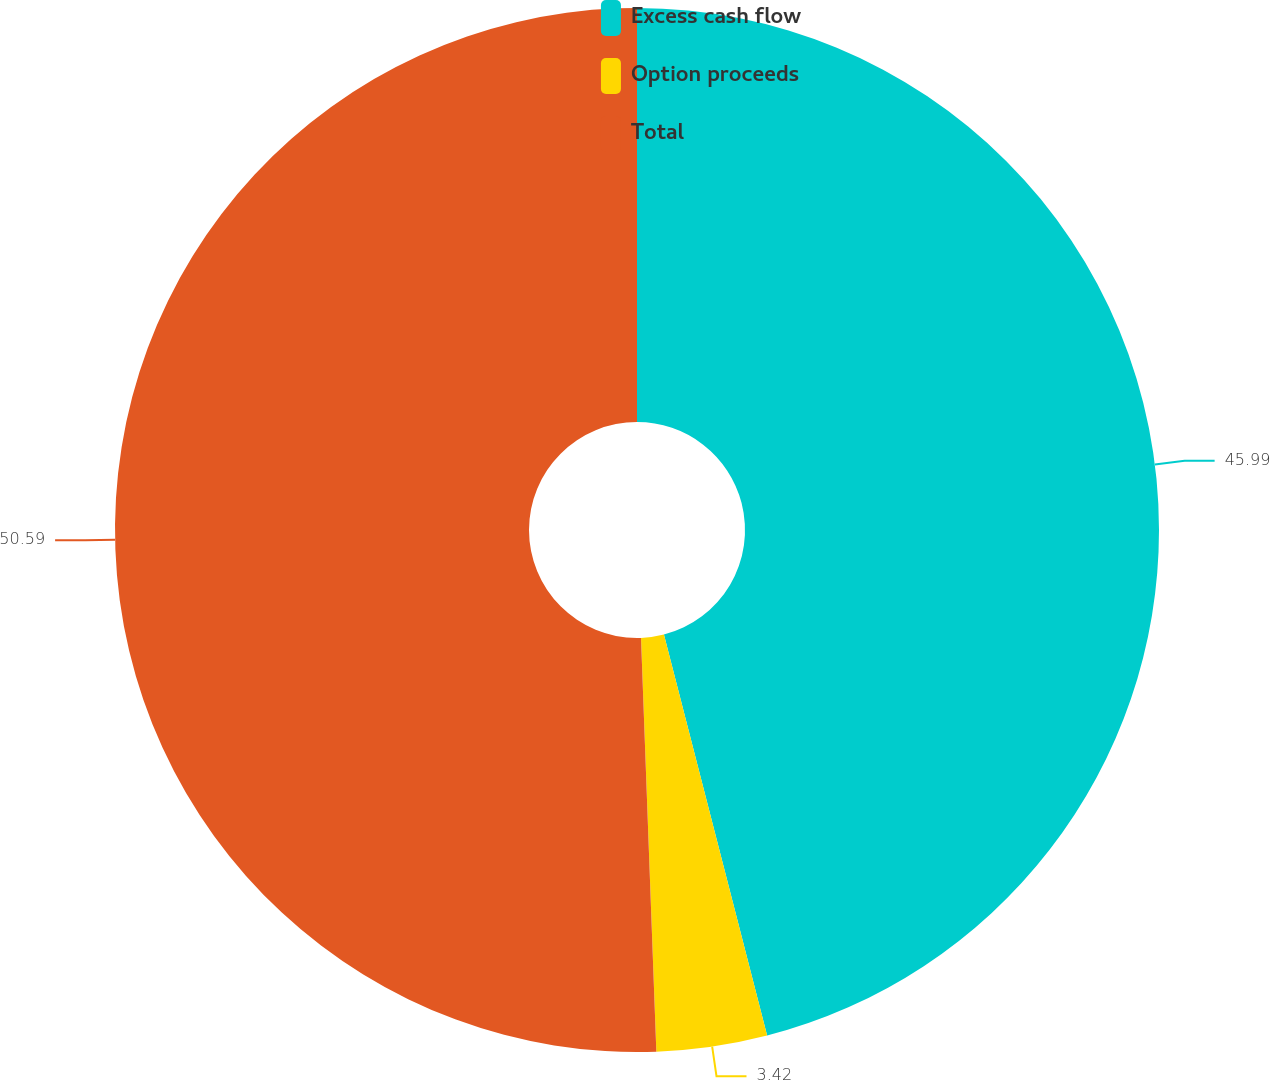Convert chart. <chart><loc_0><loc_0><loc_500><loc_500><pie_chart><fcel>Excess cash flow<fcel>Option proceeds<fcel>Total<nl><fcel>45.99%<fcel>3.42%<fcel>50.59%<nl></chart> 